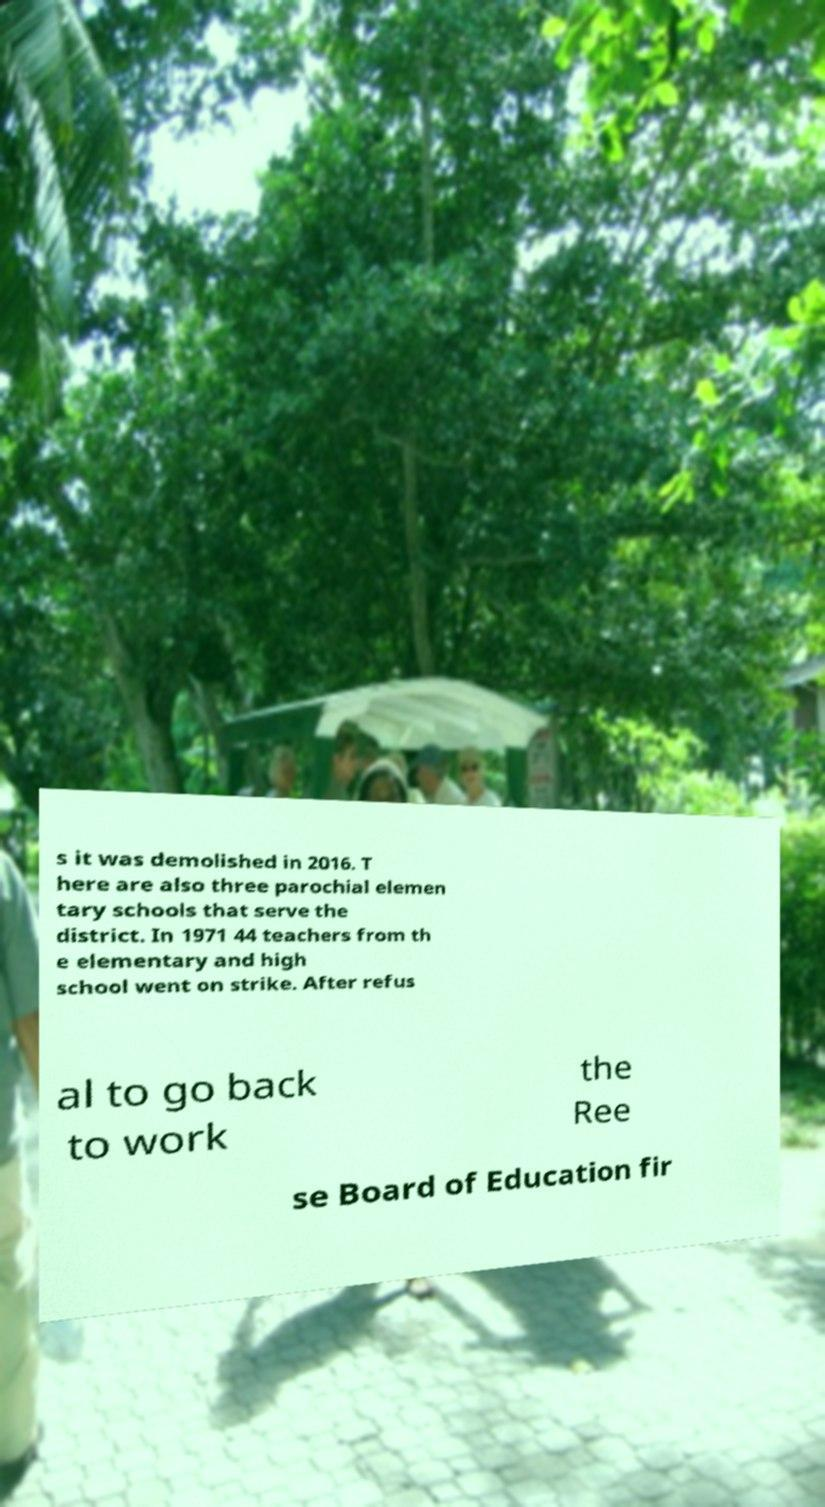Please identify and transcribe the text found in this image. s it was demolished in 2016. T here are also three parochial elemen tary schools that serve the district. In 1971 44 teachers from th e elementary and high school went on strike. After refus al to go back to work the Ree se Board of Education fir 